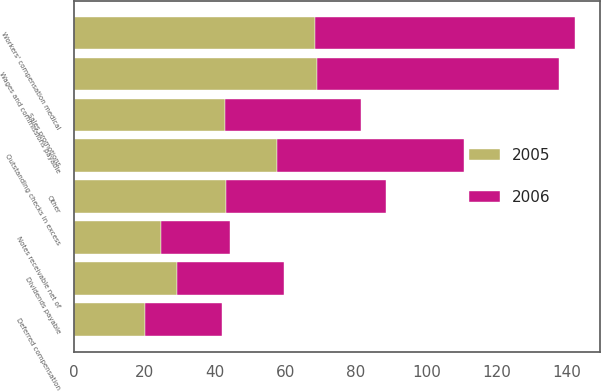Convert chart. <chart><loc_0><loc_0><loc_500><loc_500><stacked_bar_chart><ecel><fcel>Notes receivable net of<fcel>Other<fcel>Wages and commissions payable<fcel>Workers' compensation medical<fcel>Sales promotions<fcel>Outstanding checks in excess<fcel>Dividends payable<fcel>Deferred compensation<nl><fcel>2006<fcel>19.6<fcel>45.6<fcel>68.7<fcel>73.7<fcel>38.7<fcel>53<fcel>30.4<fcel>22<nl><fcel>2005<fcel>24.7<fcel>43<fcel>69.1<fcel>68.4<fcel>42.9<fcel>57.7<fcel>29.3<fcel>20<nl></chart> 